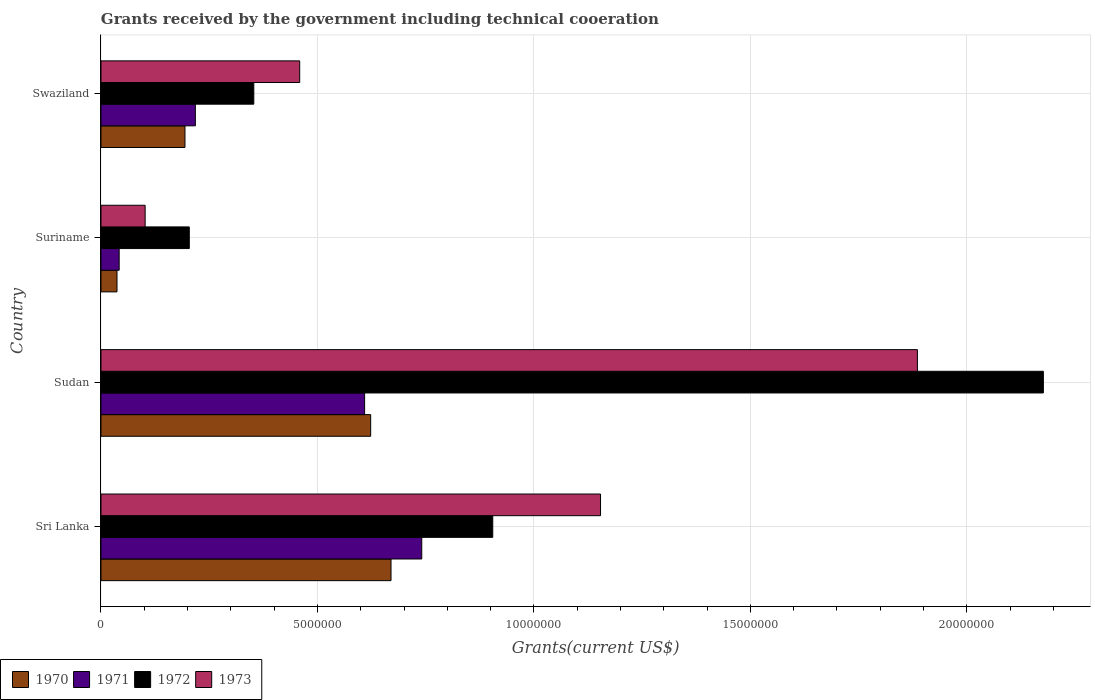Are the number of bars per tick equal to the number of legend labels?
Provide a succinct answer. Yes. Are the number of bars on each tick of the Y-axis equal?
Ensure brevity in your answer.  Yes. How many bars are there on the 2nd tick from the top?
Your answer should be compact. 4. What is the label of the 1st group of bars from the top?
Keep it short and to the point. Swaziland. In how many cases, is the number of bars for a given country not equal to the number of legend labels?
Keep it short and to the point. 0. What is the total grants received by the government in 1973 in Sudan?
Make the answer very short. 1.89e+07. Across all countries, what is the maximum total grants received by the government in 1971?
Your answer should be very brief. 7.41e+06. Across all countries, what is the minimum total grants received by the government in 1973?
Keep it short and to the point. 1.02e+06. In which country was the total grants received by the government in 1971 maximum?
Offer a terse response. Sri Lanka. In which country was the total grants received by the government in 1972 minimum?
Your response must be concise. Suriname. What is the total total grants received by the government in 1973 in the graph?
Make the answer very short. 3.60e+07. What is the difference between the total grants received by the government in 1971 in Sudan and that in Suriname?
Provide a short and direct response. 5.67e+06. What is the difference between the total grants received by the government in 1971 in Sudan and the total grants received by the government in 1970 in Suriname?
Your answer should be very brief. 5.72e+06. What is the average total grants received by the government in 1970 per country?
Ensure brevity in your answer.  3.81e+06. What is the difference between the total grants received by the government in 1970 and total grants received by the government in 1973 in Suriname?
Ensure brevity in your answer.  -6.50e+05. In how many countries, is the total grants received by the government in 1970 greater than 12000000 US$?
Ensure brevity in your answer.  0. What is the ratio of the total grants received by the government in 1971 in Sri Lanka to that in Suriname?
Provide a short and direct response. 17.64. Is the total grants received by the government in 1972 in Sudan less than that in Swaziland?
Your answer should be compact. No. Is the difference between the total grants received by the government in 1970 in Sri Lanka and Sudan greater than the difference between the total grants received by the government in 1973 in Sri Lanka and Sudan?
Provide a short and direct response. Yes. What is the difference between the highest and the second highest total grants received by the government in 1972?
Your answer should be compact. 1.27e+07. What is the difference between the highest and the lowest total grants received by the government in 1971?
Your answer should be very brief. 6.99e+06. Is the sum of the total grants received by the government in 1972 in Sri Lanka and Suriname greater than the maximum total grants received by the government in 1970 across all countries?
Provide a short and direct response. Yes. Is it the case that in every country, the sum of the total grants received by the government in 1972 and total grants received by the government in 1971 is greater than the sum of total grants received by the government in 1970 and total grants received by the government in 1973?
Make the answer very short. No. What does the 4th bar from the top in Suriname represents?
Your answer should be very brief. 1970. How many bars are there?
Offer a terse response. 16. Are all the bars in the graph horizontal?
Keep it short and to the point. Yes. What is the difference between two consecutive major ticks on the X-axis?
Your response must be concise. 5.00e+06. Are the values on the major ticks of X-axis written in scientific E-notation?
Your answer should be compact. No. Does the graph contain any zero values?
Offer a very short reply. No. Does the graph contain grids?
Keep it short and to the point. Yes. Where does the legend appear in the graph?
Keep it short and to the point. Bottom left. What is the title of the graph?
Ensure brevity in your answer.  Grants received by the government including technical cooeration. Does "2013" appear as one of the legend labels in the graph?
Give a very brief answer. No. What is the label or title of the X-axis?
Provide a short and direct response. Grants(current US$). What is the Grants(current US$) of 1970 in Sri Lanka?
Your response must be concise. 6.70e+06. What is the Grants(current US$) in 1971 in Sri Lanka?
Ensure brevity in your answer.  7.41e+06. What is the Grants(current US$) in 1972 in Sri Lanka?
Ensure brevity in your answer.  9.05e+06. What is the Grants(current US$) in 1973 in Sri Lanka?
Give a very brief answer. 1.15e+07. What is the Grants(current US$) of 1970 in Sudan?
Your response must be concise. 6.23e+06. What is the Grants(current US$) in 1971 in Sudan?
Offer a terse response. 6.09e+06. What is the Grants(current US$) in 1972 in Sudan?
Make the answer very short. 2.18e+07. What is the Grants(current US$) in 1973 in Sudan?
Provide a succinct answer. 1.89e+07. What is the Grants(current US$) in 1970 in Suriname?
Offer a terse response. 3.70e+05. What is the Grants(current US$) in 1972 in Suriname?
Your response must be concise. 2.04e+06. What is the Grants(current US$) of 1973 in Suriname?
Your answer should be very brief. 1.02e+06. What is the Grants(current US$) in 1970 in Swaziland?
Make the answer very short. 1.94e+06. What is the Grants(current US$) of 1971 in Swaziland?
Keep it short and to the point. 2.18e+06. What is the Grants(current US$) in 1972 in Swaziland?
Offer a very short reply. 3.53e+06. What is the Grants(current US$) of 1973 in Swaziland?
Keep it short and to the point. 4.59e+06. Across all countries, what is the maximum Grants(current US$) in 1970?
Give a very brief answer. 6.70e+06. Across all countries, what is the maximum Grants(current US$) in 1971?
Provide a short and direct response. 7.41e+06. Across all countries, what is the maximum Grants(current US$) of 1972?
Your answer should be very brief. 2.18e+07. Across all countries, what is the maximum Grants(current US$) of 1973?
Offer a very short reply. 1.89e+07. Across all countries, what is the minimum Grants(current US$) of 1970?
Ensure brevity in your answer.  3.70e+05. Across all countries, what is the minimum Grants(current US$) in 1972?
Your response must be concise. 2.04e+06. Across all countries, what is the minimum Grants(current US$) in 1973?
Keep it short and to the point. 1.02e+06. What is the total Grants(current US$) in 1970 in the graph?
Keep it short and to the point. 1.52e+07. What is the total Grants(current US$) of 1971 in the graph?
Provide a short and direct response. 1.61e+07. What is the total Grants(current US$) of 1972 in the graph?
Provide a short and direct response. 3.64e+07. What is the total Grants(current US$) in 1973 in the graph?
Your answer should be compact. 3.60e+07. What is the difference between the Grants(current US$) in 1970 in Sri Lanka and that in Sudan?
Your answer should be compact. 4.70e+05. What is the difference between the Grants(current US$) in 1971 in Sri Lanka and that in Sudan?
Your answer should be compact. 1.32e+06. What is the difference between the Grants(current US$) in 1972 in Sri Lanka and that in Sudan?
Offer a terse response. -1.27e+07. What is the difference between the Grants(current US$) in 1973 in Sri Lanka and that in Sudan?
Provide a succinct answer. -7.32e+06. What is the difference between the Grants(current US$) of 1970 in Sri Lanka and that in Suriname?
Offer a very short reply. 6.33e+06. What is the difference between the Grants(current US$) in 1971 in Sri Lanka and that in Suriname?
Your answer should be very brief. 6.99e+06. What is the difference between the Grants(current US$) of 1972 in Sri Lanka and that in Suriname?
Your response must be concise. 7.01e+06. What is the difference between the Grants(current US$) in 1973 in Sri Lanka and that in Suriname?
Your response must be concise. 1.05e+07. What is the difference between the Grants(current US$) in 1970 in Sri Lanka and that in Swaziland?
Your answer should be compact. 4.76e+06. What is the difference between the Grants(current US$) in 1971 in Sri Lanka and that in Swaziland?
Your response must be concise. 5.23e+06. What is the difference between the Grants(current US$) of 1972 in Sri Lanka and that in Swaziland?
Offer a very short reply. 5.52e+06. What is the difference between the Grants(current US$) in 1973 in Sri Lanka and that in Swaziland?
Offer a very short reply. 6.95e+06. What is the difference between the Grants(current US$) of 1970 in Sudan and that in Suriname?
Provide a succinct answer. 5.86e+06. What is the difference between the Grants(current US$) in 1971 in Sudan and that in Suriname?
Your answer should be compact. 5.67e+06. What is the difference between the Grants(current US$) in 1972 in Sudan and that in Suriname?
Provide a succinct answer. 1.97e+07. What is the difference between the Grants(current US$) of 1973 in Sudan and that in Suriname?
Provide a succinct answer. 1.78e+07. What is the difference between the Grants(current US$) of 1970 in Sudan and that in Swaziland?
Make the answer very short. 4.29e+06. What is the difference between the Grants(current US$) of 1971 in Sudan and that in Swaziland?
Keep it short and to the point. 3.91e+06. What is the difference between the Grants(current US$) in 1972 in Sudan and that in Swaziland?
Your answer should be very brief. 1.82e+07. What is the difference between the Grants(current US$) of 1973 in Sudan and that in Swaziland?
Offer a very short reply. 1.43e+07. What is the difference between the Grants(current US$) in 1970 in Suriname and that in Swaziland?
Your answer should be compact. -1.57e+06. What is the difference between the Grants(current US$) in 1971 in Suriname and that in Swaziland?
Ensure brevity in your answer.  -1.76e+06. What is the difference between the Grants(current US$) of 1972 in Suriname and that in Swaziland?
Your answer should be very brief. -1.49e+06. What is the difference between the Grants(current US$) of 1973 in Suriname and that in Swaziland?
Keep it short and to the point. -3.57e+06. What is the difference between the Grants(current US$) in 1970 in Sri Lanka and the Grants(current US$) in 1971 in Sudan?
Keep it short and to the point. 6.10e+05. What is the difference between the Grants(current US$) in 1970 in Sri Lanka and the Grants(current US$) in 1972 in Sudan?
Your answer should be very brief. -1.51e+07. What is the difference between the Grants(current US$) in 1970 in Sri Lanka and the Grants(current US$) in 1973 in Sudan?
Give a very brief answer. -1.22e+07. What is the difference between the Grants(current US$) of 1971 in Sri Lanka and the Grants(current US$) of 1972 in Sudan?
Ensure brevity in your answer.  -1.44e+07. What is the difference between the Grants(current US$) of 1971 in Sri Lanka and the Grants(current US$) of 1973 in Sudan?
Your response must be concise. -1.14e+07. What is the difference between the Grants(current US$) of 1972 in Sri Lanka and the Grants(current US$) of 1973 in Sudan?
Offer a very short reply. -9.81e+06. What is the difference between the Grants(current US$) in 1970 in Sri Lanka and the Grants(current US$) in 1971 in Suriname?
Your answer should be very brief. 6.28e+06. What is the difference between the Grants(current US$) in 1970 in Sri Lanka and the Grants(current US$) in 1972 in Suriname?
Offer a very short reply. 4.66e+06. What is the difference between the Grants(current US$) in 1970 in Sri Lanka and the Grants(current US$) in 1973 in Suriname?
Offer a terse response. 5.68e+06. What is the difference between the Grants(current US$) of 1971 in Sri Lanka and the Grants(current US$) of 1972 in Suriname?
Make the answer very short. 5.37e+06. What is the difference between the Grants(current US$) of 1971 in Sri Lanka and the Grants(current US$) of 1973 in Suriname?
Provide a succinct answer. 6.39e+06. What is the difference between the Grants(current US$) in 1972 in Sri Lanka and the Grants(current US$) in 1973 in Suriname?
Ensure brevity in your answer.  8.03e+06. What is the difference between the Grants(current US$) in 1970 in Sri Lanka and the Grants(current US$) in 1971 in Swaziland?
Offer a terse response. 4.52e+06. What is the difference between the Grants(current US$) in 1970 in Sri Lanka and the Grants(current US$) in 1972 in Swaziland?
Ensure brevity in your answer.  3.17e+06. What is the difference between the Grants(current US$) of 1970 in Sri Lanka and the Grants(current US$) of 1973 in Swaziland?
Offer a very short reply. 2.11e+06. What is the difference between the Grants(current US$) in 1971 in Sri Lanka and the Grants(current US$) in 1972 in Swaziland?
Offer a terse response. 3.88e+06. What is the difference between the Grants(current US$) in 1971 in Sri Lanka and the Grants(current US$) in 1973 in Swaziland?
Make the answer very short. 2.82e+06. What is the difference between the Grants(current US$) of 1972 in Sri Lanka and the Grants(current US$) of 1973 in Swaziland?
Keep it short and to the point. 4.46e+06. What is the difference between the Grants(current US$) of 1970 in Sudan and the Grants(current US$) of 1971 in Suriname?
Provide a succinct answer. 5.81e+06. What is the difference between the Grants(current US$) of 1970 in Sudan and the Grants(current US$) of 1972 in Suriname?
Keep it short and to the point. 4.19e+06. What is the difference between the Grants(current US$) in 1970 in Sudan and the Grants(current US$) in 1973 in Suriname?
Keep it short and to the point. 5.21e+06. What is the difference between the Grants(current US$) of 1971 in Sudan and the Grants(current US$) of 1972 in Suriname?
Offer a very short reply. 4.05e+06. What is the difference between the Grants(current US$) of 1971 in Sudan and the Grants(current US$) of 1973 in Suriname?
Provide a succinct answer. 5.07e+06. What is the difference between the Grants(current US$) in 1972 in Sudan and the Grants(current US$) in 1973 in Suriname?
Ensure brevity in your answer.  2.08e+07. What is the difference between the Grants(current US$) in 1970 in Sudan and the Grants(current US$) in 1971 in Swaziland?
Give a very brief answer. 4.05e+06. What is the difference between the Grants(current US$) in 1970 in Sudan and the Grants(current US$) in 1972 in Swaziland?
Provide a succinct answer. 2.70e+06. What is the difference between the Grants(current US$) of 1970 in Sudan and the Grants(current US$) of 1973 in Swaziland?
Ensure brevity in your answer.  1.64e+06. What is the difference between the Grants(current US$) in 1971 in Sudan and the Grants(current US$) in 1972 in Swaziland?
Give a very brief answer. 2.56e+06. What is the difference between the Grants(current US$) of 1971 in Sudan and the Grants(current US$) of 1973 in Swaziland?
Ensure brevity in your answer.  1.50e+06. What is the difference between the Grants(current US$) in 1972 in Sudan and the Grants(current US$) in 1973 in Swaziland?
Your answer should be very brief. 1.72e+07. What is the difference between the Grants(current US$) in 1970 in Suriname and the Grants(current US$) in 1971 in Swaziland?
Your answer should be very brief. -1.81e+06. What is the difference between the Grants(current US$) in 1970 in Suriname and the Grants(current US$) in 1972 in Swaziland?
Offer a very short reply. -3.16e+06. What is the difference between the Grants(current US$) in 1970 in Suriname and the Grants(current US$) in 1973 in Swaziland?
Provide a succinct answer. -4.22e+06. What is the difference between the Grants(current US$) of 1971 in Suriname and the Grants(current US$) of 1972 in Swaziland?
Keep it short and to the point. -3.11e+06. What is the difference between the Grants(current US$) of 1971 in Suriname and the Grants(current US$) of 1973 in Swaziland?
Your response must be concise. -4.17e+06. What is the difference between the Grants(current US$) in 1972 in Suriname and the Grants(current US$) in 1973 in Swaziland?
Ensure brevity in your answer.  -2.55e+06. What is the average Grants(current US$) in 1970 per country?
Make the answer very short. 3.81e+06. What is the average Grants(current US$) in 1971 per country?
Keep it short and to the point. 4.02e+06. What is the average Grants(current US$) of 1972 per country?
Provide a short and direct response. 9.10e+06. What is the average Grants(current US$) in 1973 per country?
Your answer should be very brief. 9.00e+06. What is the difference between the Grants(current US$) of 1970 and Grants(current US$) of 1971 in Sri Lanka?
Keep it short and to the point. -7.10e+05. What is the difference between the Grants(current US$) in 1970 and Grants(current US$) in 1972 in Sri Lanka?
Your response must be concise. -2.35e+06. What is the difference between the Grants(current US$) of 1970 and Grants(current US$) of 1973 in Sri Lanka?
Provide a succinct answer. -4.84e+06. What is the difference between the Grants(current US$) of 1971 and Grants(current US$) of 1972 in Sri Lanka?
Give a very brief answer. -1.64e+06. What is the difference between the Grants(current US$) of 1971 and Grants(current US$) of 1973 in Sri Lanka?
Provide a succinct answer. -4.13e+06. What is the difference between the Grants(current US$) in 1972 and Grants(current US$) in 1973 in Sri Lanka?
Ensure brevity in your answer.  -2.49e+06. What is the difference between the Grants(current US$) in 1970 and Grants(current US$) in 1972 in Sudan?
Your answer should be very brief. -1.55e+07. What is the difference between the Grants(current US$) in 1970 and Grants(current US$) in 1973 in Sudan?
Provide a short and direct response. -1.26e+07. What is the difference between the Grants(current US$) in 1971 and Grants(current US$) in 1972 in Sudan?
Provide a succinct answer. -1.57e+07. What is the difference between the Grants(current US$) in 1971 and Grants(current US$) in 1973 in Sudan?
Offer a very short reply. -1.28e+07. What is the difference between the Grants(current US$) in 1972 and Grants(current US$) in 1973 in Sudan?
Offer a very short reply. 2.91e+06. What is the difference between the Grants(current US$) in 1970 and Grants(current US$) in 1971 in Suriname?
Give a very brief answer. -5.00e+04. What is the difference between the Grants(current US$) of 1970 and Grants(current US$) of 1972 in Suriname?
Make the answer very short. -1.67e+06. What is the difference between the Grants(current US$) of 1970 and Grants(current US$) of 1973 in Suriname?
Offer a very short reply. -6.50e+05. What is the difference between the Grants(current US$) in 1971 and Grants(current US$) in 1972 in Suriname?
Make the answer very short. -1.62e+06. What is the difference between the Grants(current US$) of 1971 and Grants(current US$) of 1973 in Suriname?
Ensure brevity in your answer.  -6.00e+05. What is the difference between the Grants(current US$) of 1972 and Grants(current US$) of 1973 in Suriname?
Make the answer very short. 1.02e+06. What is the difference between the Grants(current US$) in 1970 and Grants(current US$) in 1971 in Swaziland?
Your answer should be very brief. -2.40e+05. What is the difference between the Grants(current US$) in 1970 and Grants(current US$) in 1972 in Swaziland?
Give a very brief answer. -1.59e+06. What is the difference between the Grants(current US$) in 1970 and Grants(current US$) in 1973 in Swaziland?
Your response must be concise. -2.65e+06. What is the difference between the Grants(current US$) in 1971 and Grants(current US$) in 1972 in Swaziland?
Provide a succinct answer. -1.35e+06. What is the difference between the Grants(current US$) in 1971 and Grants(current US$) in 1973 in Swaziland?
Your response must be concise. -2.41e+06. What is the difference between the Grants(current US$) in 1972 and Grants(current US$) in 1973 in Swaziland?
Your response must be concise. -1.06e+06. What is the ratio of the Grants(current US$) of 1970 in Sri Lanka to that in Sudan?
Your answer should be compact. 1.08. What is the ratio of the Grants(current US$) in 1971 in Sri Lanka to that in Sudan?
Ensure brevity in your answer.  1.22. What is the ratio of the Grants(current US$) of 1972 in Sri Lanka to that in Sudan?
Your answer should be compact. 0.42. What is the ratio of the Grants(current US$) in 1973 in Sri Lanka to that in Sudan?
Your answer should be very brief. 0.61. What is the ratio of the Grants(current US$) in 1970 in Sri Lanka to that in Suriname?
Offer a terse response. 18.11. What is the ratio of the Grants(current US$) of 1971 in Sri Lanka to that in Suriname?
Offer a very short reply. 17.64. What is the ratio of the Grants(current US$) in 1972 in Sri Lanka to that in Suriname?
Offer a terse response. 4.44. What is the ratio of the Grants(current US$) in 1973 in Sri Lanka to that in Suriname?
Keep it short and to the point. 11.31. What is the ratio of the Grants(current US$) of 1970 in Sri Lanka to that in Swaziland?
Make the answer very short. 3.45. What is the ratio of the Grants(current US$) of 1971 in Sri Lanka to that in Swaziland?
Ensure brevity in your answer.  3.4. What is the ratio of the Grants(current US$) of 1972 in Sri Lanka to that in Swaziland?
Give a very brief answer. 2.56. What is the ratio of the Grants(current US$) in 1973 in Sri Lanka to that in Swaziland?
Your response must be concise. 2.51. What is the ratio of the Grants(current US$) of 1970 in Sudan to that in Suriname?
Your answer should be compact. 16.84. What is the ratio of the Grants(current US$) in 1972 in Sudan to that in Suriname?
Keep it short and to the point. 10.67. What is the ratio of the Grants(current US$) of 1973 in Sudan to that in Suriname?
Your answer should be very brief. 18.49. What is the ratio of the Grants(current US$) of 1970 in Sudan to that in Swaziland?
Your answer should be compact. 3.21. What is the ratio of the Grants(current US$) in 1971 in Sudan to that in Swaziland?
Keep it short and to the point. 2.79. What is the ratio of the Grants(current US$) in 1972 in Sudan to that in Swaziland?
Provide a short and direct response. 6.17. What is the ratio of the Grants(current US$) in 1973 in Sudan to that in Swaziland?
Provide a short and direct response. 4.11. What is the ratio of the Grants(current US$) of 1970 in Suriname to that in Swaziland?
Your response must be concise. 0.19. What is the ratio of the Grants(current US$) of 1971 in Suriname to that in Swaziland?
Make the answer very short. 0.19. What is the ratio of the Grants(current US$) of 1972 in Suriname to that in Swaziland?
Give a very brief answer. 0.58. What is the ratio of the Grants(current US$) of 1973 in Suriname to that in Swaziland?
Keep it short and to the point. 0.22. What is the difference between the highest and the second highest Grants(current US$) in 1970?
Keep it short and to the point. 4.70e+05. What is the difference between the highest and the second highest Grants(current US$) of 1971?
Give a very brief answer. 1.32e+06. What is the difference between the highest and the second highest Grants(current US$) of 1972?
Ensure brevity in your answer.  1.27e+07. What is the difference between the highest and the second highest Grants(current US$) of 1973?
Give a very brief answer. 7.32e+06. What is the difference between the highest and the lowest Grants(current US$) of 1970?
Offer a very short reply. 6.33e+06. What is the difference between the highest and the lowest Grants(current US$) in 1971?
Ensure brevity in your answer.  6.99e+06. What is the difference between the highest and the lowest Grants(current US$) of 1972?
Offer a very short reply. 1.97e+07. What is the difference between the highest and the lowest Grants(current US$) in 1973?
Provide a short and direct response. 1.78e+07. 